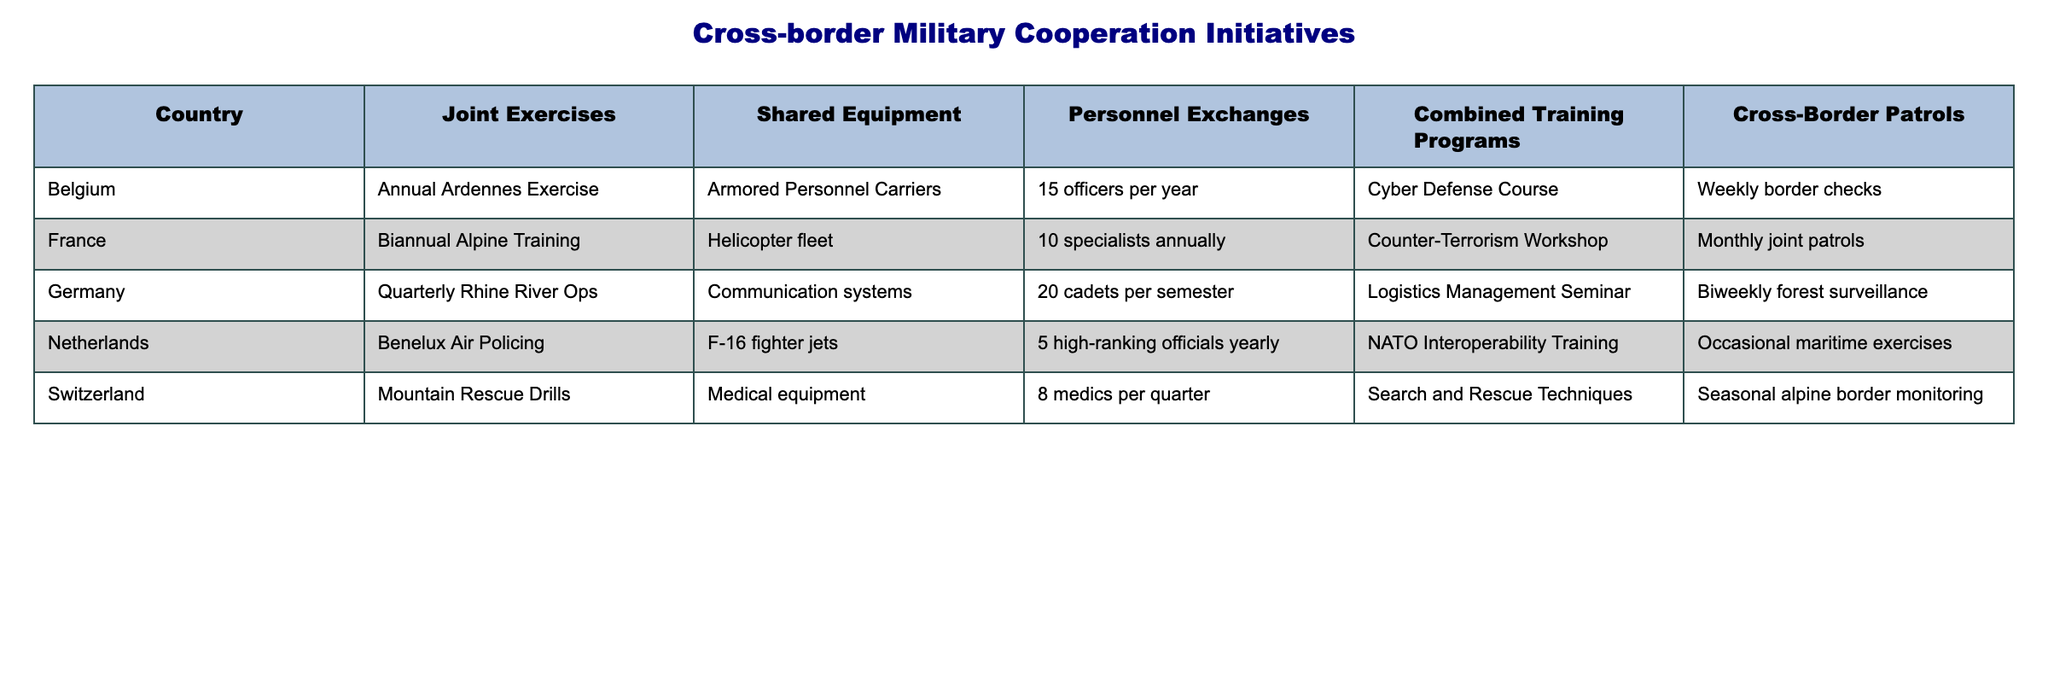What joint exercise is conducted by France? The table lists "Biannual Alpine Training" as the joint exercise conducted by France.
Answer: Biannual Alpine Training Which country has the highest number of personnel exchanges per year? Germany has 20 cadets per semester, which translates to 40 per year, making it the highest among the countries listed.
Answer: Germany Does Switzerland conduct joint patrols? The table indicates that Switzerland performs "Seasonal alpine border monitoring," which is a form of border surveillance, rather than joint patrols.
Answer: No If we sum the personnel exchanges for all countries, what is the total? Adding them together: 15 (Belgium) + 10 (France) + 20 (Germany) + 5 (Netherlands) + 8 (Switzerland) = 68 personnel exchanges per year total.
Answer: 68 Which country participates in the most frequent joint exercises, and how often do they occur? Germany conducts joint exercises quarterly, which is more frequent than any other country listed.
Answer: Germany; Quarterly Is there any country that shares medical equipment in their cross-border military initiatives? Yes, the table states that Switzerland shares medical equipment as part of their initiatives.
Answer: Yes How many different types of shared equipment are reported across all countries? The table lists five types of shared equipment: Armored Personnel Carriers, Helicopter fleet, Communication systems, F-16 fighter jets, and Medical equipment, totaling five.
Answer: 5 Are Belgium's border checks more frequent than France's joint patrols? Belgium performs weekly border checks, whereas France conducts monthly joint patrols. Weekly is more frequent than monthly.
Answer: Yes What is the difference in the number of personnel exchanged between Germany and the Netherlands? Germany exchanges 20 cadets per semester (40 per year) while the Netherlands exchanges 5 high-ranking officials yearly. The difference is 40 - 5 = 35 personnel.
Answer: 35 Which country has the least number of shared equipment, and what is the specific equipment? The Netherlands has the least, sharing only F-16 fighter jets as reported in the table.
Answer: Netherlands; F-16 fighter jets 